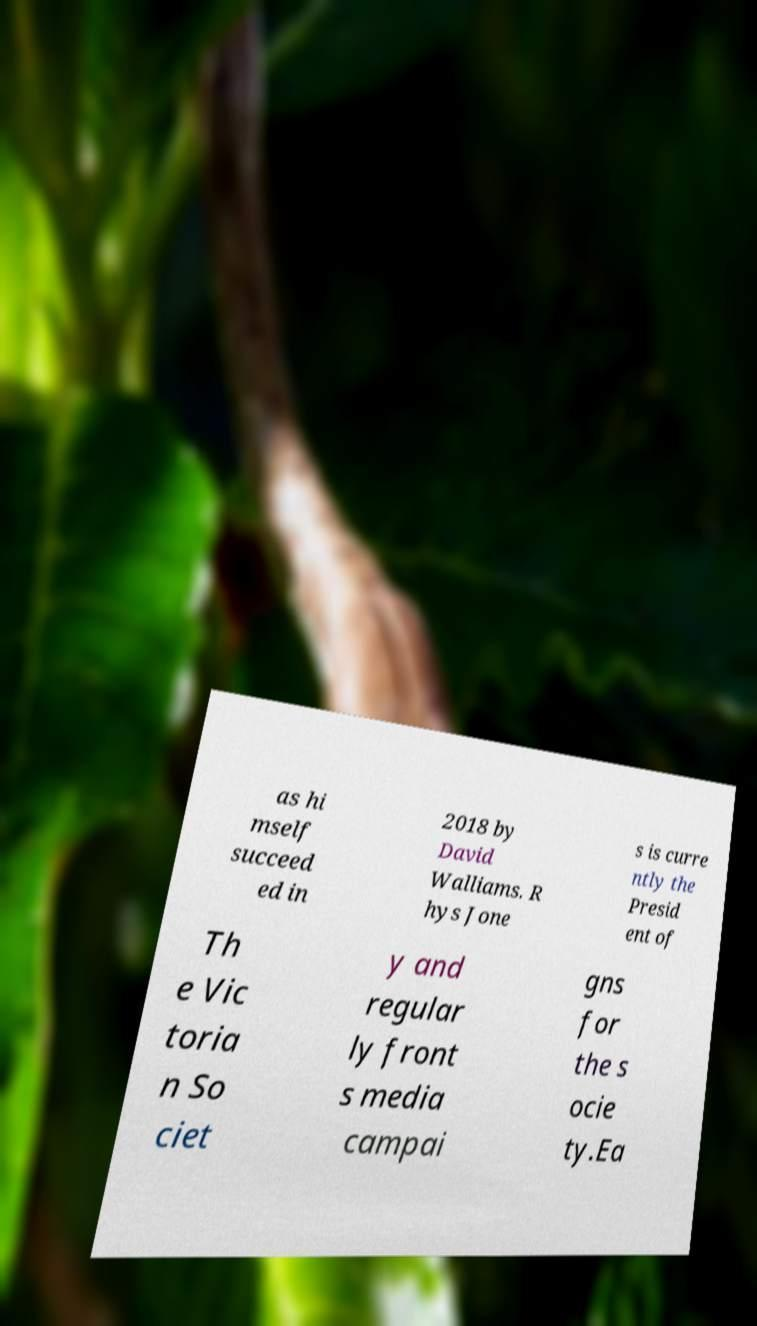Can you read and provide the text displayed in the image?This photo seems to have some interesting text. Can you extract and type it out for me? as hi mself succeed ed in 2018 by David Walliams. R hys Jone s is curre ntly the Presid ent of Th e Vic toria n So ciet y and regular ly front s media campai gns for the s ocie ty.Ea 